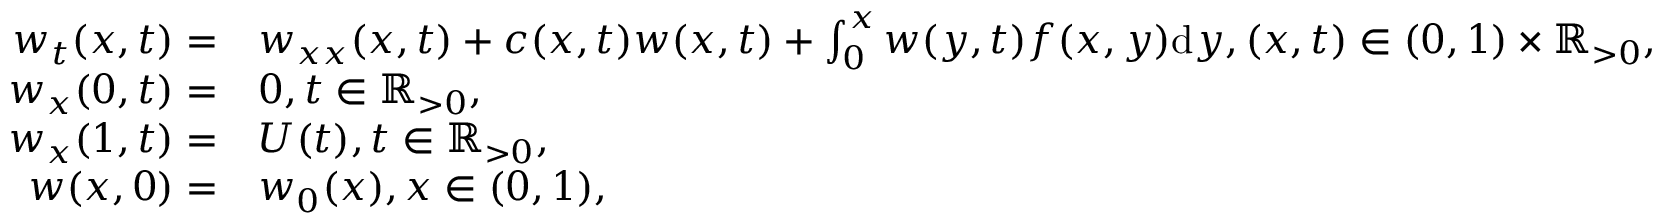<formula> <loc_0><loc_0><loc_500><loc_500>\begin{array} { r l } { w _ { t } ( x , t ) = } & { w _ { x x } ( x , t ) + c ( x , t ) w ( x , t ) + \int _ { 0 } ^ { x } w ( y , t ) f ( x , y ) d y , ( x , t ) \in ( 0 , 1 ) \times { \mathbb { R } _ { > 0 } } , } \\ { w _ { x } ( 0 , t ) = } & { 0 , t \in { \mathbb { R } _ { > 0 } } , } \\ { w _ { x } ( 1 , t ) = } & { U ( t ) , t \in { \mathbb { R } _ { > 0 } } , } \\ { w ( x , 0 ) = } & { w _ { 0 } ( x ) , x \in ( 0 , 1 ) , } \end{array}</formula> 